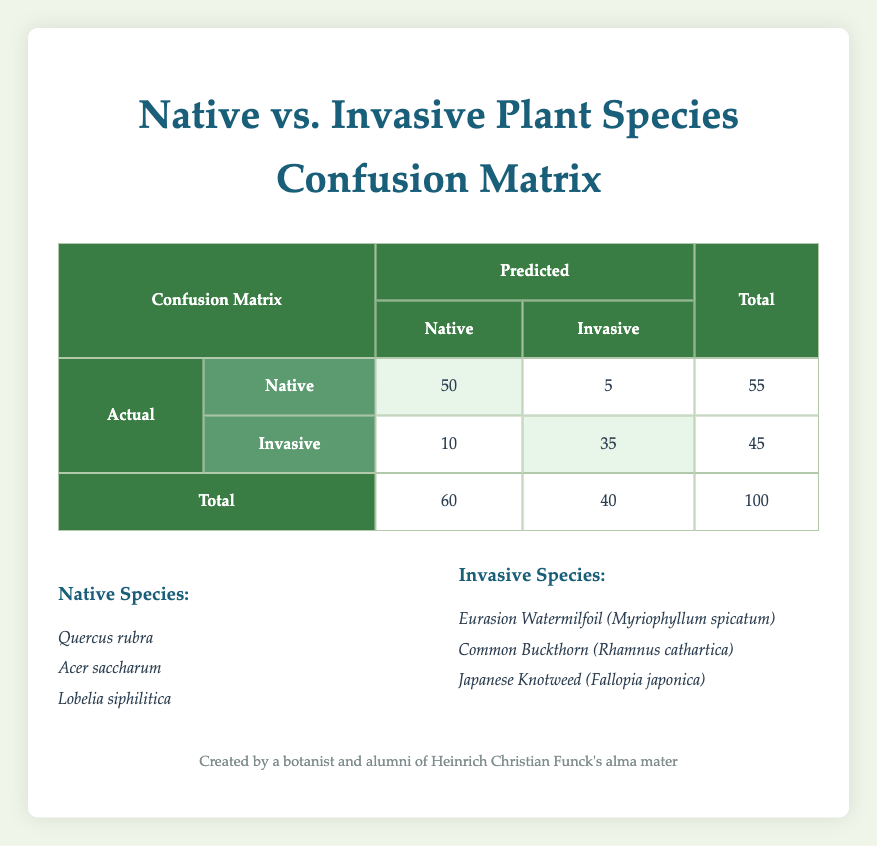What is the total number of actual native species predicted as native? The confusion matrix shows that 50 actual native species were categorized correctly as native, and 5 were misclassified as invasive. To find the total predicted as native, we refer to the column under "Predicted" and can see the total for native is 60, which aligns with the correctness
Answer: 60 What is the total number of actual invasive species predicted as invasive? In the confusion matrix, there are 35 actual invasive species that were predicted correctly as invasive and 10 that were misclassified as native. Therefore, the total number of actual invasive species predicted as invasive corresponds to the second row under "Predicted" column, which shows the total for invasive is 45
Answer: 45 How many actual native species were misclassified as invasive? According to the confusion matrix, 5 actual native species were incorrectly predicted as invasive. This value can be directly read from the row that contains actual natives, under the invasive predicted column
Answer: 5 What is the misclassification rate for actual native species? To find the misclassification rate for actual native species, we look at the number of native species that were misclassified. This is 5 out of 55 total actual native species (50 native + 5 invasive). The misclassification rate is calculated as (5/55) * 100 = 9.09%. Thus, it can be inferred that about 9.09% of the native species were misclassified as invasive
Answer: 9.09% Is the number of native species correctly identified greater than the number of invasive species correctly identified? Reviewing the confusion matrix, we see that there are 50 native species correctly identified compared to 35 invasive species correctly identified. Since 50 is greater than 35, the statement is true
Answer: Yes What is the sum of all actual invasive species? According to the confusion matrix, there are 10 actual native species misidentified as invasive and 35 actual invasive species correctly identified. So, to calculate the total number of actual invasive species, we add these two numbers together: 10 + 35 = 45
Answer: 45 What is the false positive rate of predicting native species? The false positive rate for predicting native species refers to the proportion of the invasive species that were incorrectly predicted as native. There are 10 actual invasive species predicted wrongly as native. To find this rate, we use the formula (false positives / total actual invasive), which is (10/45) * 100 = 22.22%. This represents the percentage of invasive species that were incorrectly labeled as native
Answer: 22.22% What is the percentage of correctly predicted actual species (both native and invasive)? First, we need to sum the correctly predicted actual species: 50 native + 35 invasive = 85 correct predictions. Then, to find the percentage of correctly predicted species, we use the formula (correct predictions / total predictions) * 100, which is (85/100) * 100 = 85%. This means that 85% of all species were predicted correctly
Answer: 85% 